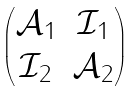<formula> <loc_0><loc_0><loc_500><loc_500>\begin{pmatrix} { \mathcal { A } _ { 1 } } & { \mathcal { I } _ { 1 } } \\ { \mathcal { I } _ { 2 } } & { \mathcal { A } _ { 2 } } \end{pmatrix}</formula> 